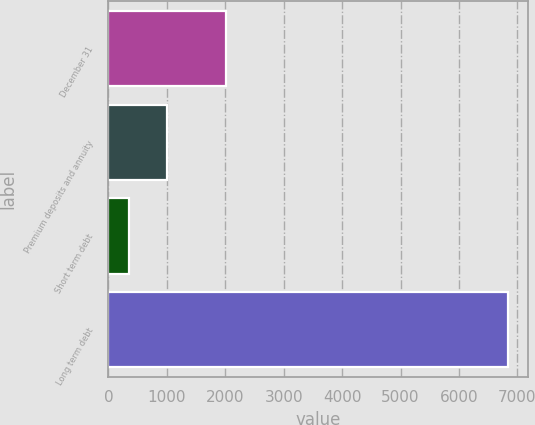Convert chart to OTSL. <chart><loc_0><loc_0><loc_500><loc_500><bar_chart><fcel>December 31<fcel>Premium deposits and annuity<fcel>Short term debt<fcel>Long term debt<nl><fcel>2007<fcel>1006.8<fcel>358<fcel>6846<nl></chart> 